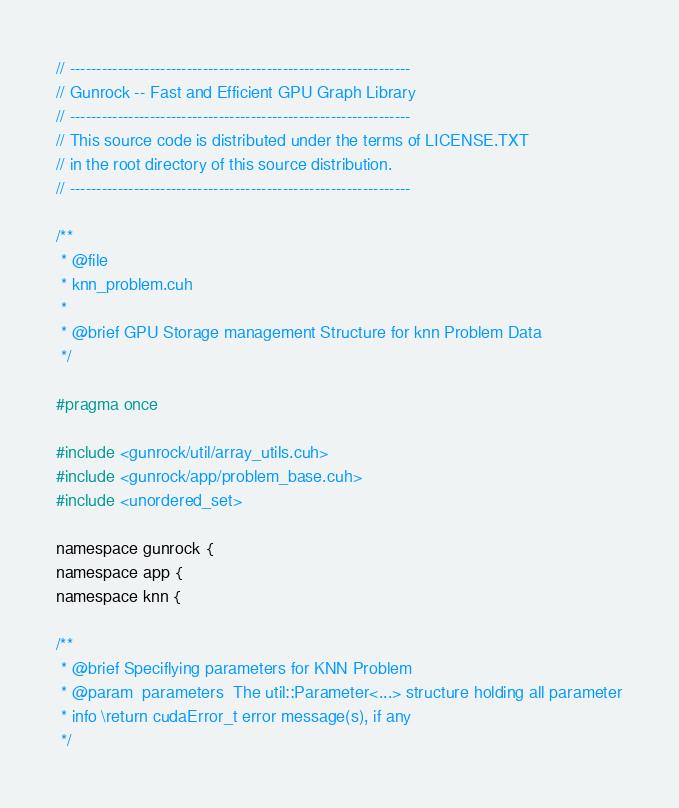<code> <loc_0><loc_0><loc_500><loc_500><_Cuda_>// ----------------------------------------------------------------
// Gunrock -- Fast and Efficient GPU Graph Library
// ----------------------------------------------------------------
// This source code is distributed under the terms of LICENSE.TXT
// in the root directory of this source distribution.
// ----------------------------------------------------------------

/**
 * @file
 * knn_problem.cuh
 *
 * @brief GPU Storage management Structure for knn Problem Data
 */

#pragma once

#include <gunrock/util/array_utils.cuh>
#include <gunrock/app/problem_base.cuh>
#include <unordered_set>

namespace gunrock {
namespace app {
namespace knn {

/**
 * @brief Speciflying parameters for KNN Problem
 * @param  parameters  The util::Parameter<...> structure holding all parameter
 * info \return cudaError_t error message(s), if any
 */</code> 